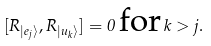<formula> <loc_0><loc_0><loc_500><loc_500>[ R _ { | e _ { j } \rangle } , R _ { | u _ { k } \rangle } ] = 0 \, \text {for} \, k > j .</formula> 